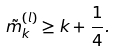Convert formula to latex. <formula><loc_0><loc_0><loc_500><loc_500>\tilde { m } _ { k } ^ { ( l ) } \geq k + \frac { 1 } { 4 } .</formula> 